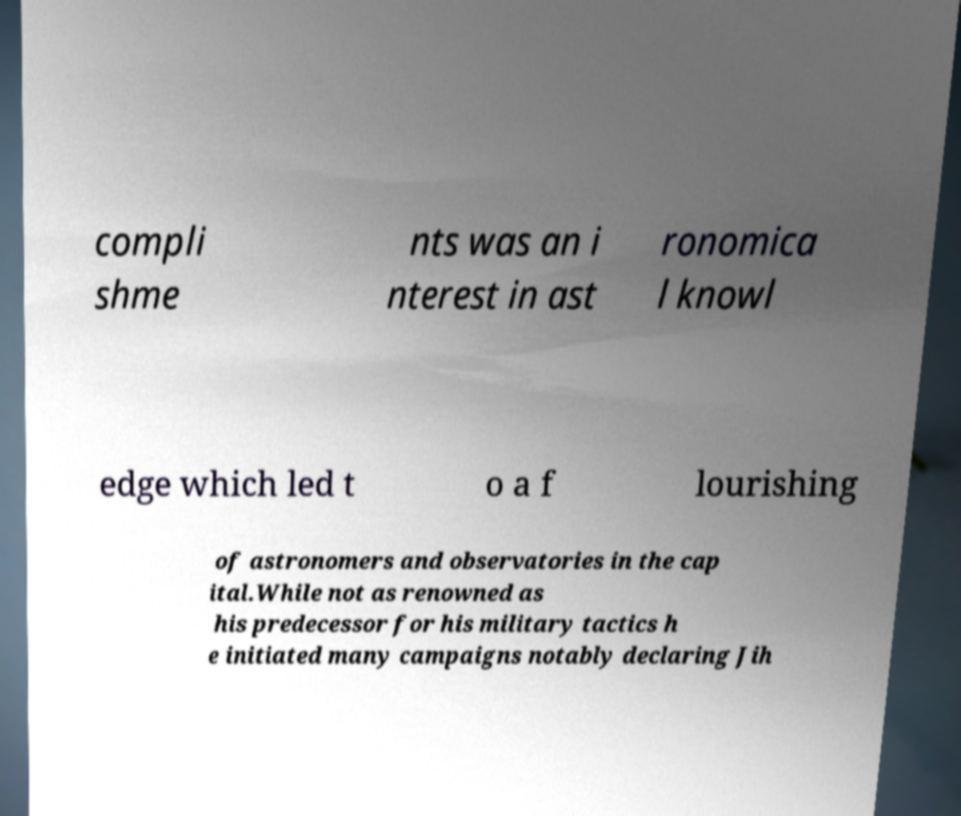Could you extract and type out the text from this image? compli shme nts was an i nterest in ast ronomica l knowl edge which led t o a f lourishing of astronomers and observatories in the cap ital.While not as renowned as his predecessor for his military tactics h e initiated many campaigns notably declaring Jih 